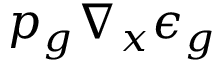<formula> <loc_0><loc_0><loc_500><loc_500>p _ { g } \nabla _ { x } \epsilon _ { g }</formula> 